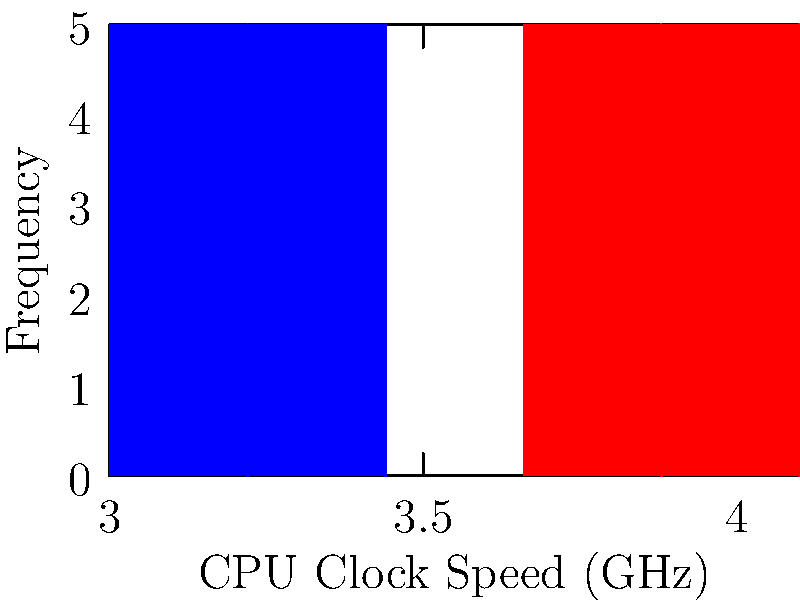Analyze the histograms showing CPU clock speeds before and after overclocking. What is the approximate percentage increase in the median clock speed achieved through overclocking? To solve this problem, we need to follow these steps:

1. Identify the median clock speed before overclocking:
   - The blue histogram represents the "Before" data.
   - The median appears to be around 3.2-3.3 GHz.
   Let's estimate it as 3.25 GHz.

2. Identify the median clock speed after overclocking:
   - The red histogram represents the "After" data.
   - The median appears to be around 3.8-3.9 GHz.
   Let's estimate it as 3.85 GHz.

3. Calculate the percentage increase:
   - Use the formula: Percentage increase = (New value - Original value) / Original value * 100
   - Percentage increase = (3.85 - 3.25) / 3.25 * 100
   - Percentage increase = 0.6 / 3.25 * 100
   - Percentage increase ≈ 18.46%

4. Round to the nearest whole percentage:
   18.46% rounds to 18%

Therefore, the approximate percentage increase in the median clock speed achieved through overclocking is 18%.
Answer: 18% 